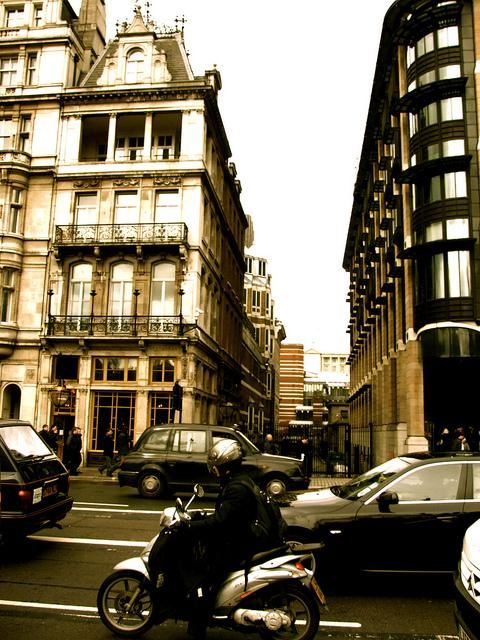How many motorcycles do you see? one 